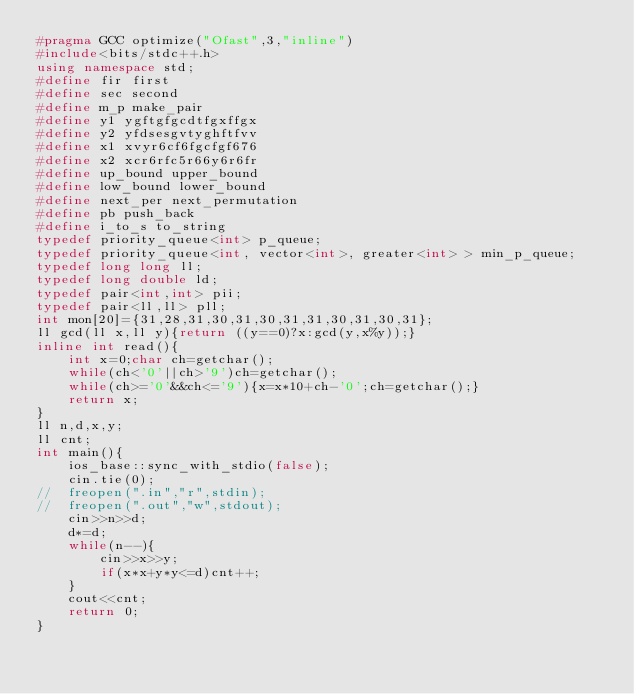<code> <loc_0><loc_0><loc_500><loc_500><_C++_>#pragma GCC optimize("Ofast",3,"inline")
#include<bits/stdc++.h>
using namespace std;
#define fir first
#define sec second
#define m_p make_pair
#define y1 ygftgfgcdtfgxffgx
#define y2 yfdsesgvtyghftfvv
#define x1 xvyr6cf6fgcfgf676
#define x2 xcr6rfc5r66y6r6fr
#define up_bound upper_bound
#define low_bound lower_bound
#define next_per next_permutation
#define pb push_back
#define i_to_s to_string
typedef priority_queue<int> p_queue;
typedef priority_queue<int, vector<int>, greater<int> > min_p_queue;
typedef long long ll;
typedef long double ld;
typedef pair<int,int> pii;
typedef pair<ll,ll> pll;
int mon[20]={31,28,31,30,31,30,31,31,30,31,30,31};
ll gcd(ll x,ll y){return ((y==0)?x:gcd(y,x%y));}
inline int read(){
	int x=0;char ch=getchar();
	while(ch<'0'||ch>'9')ch=getchar();
	while(ch>='0'&&ch<='9'){x=x*10+ch-'0';ch=getchar();}
	return x;
}
ll n,d,x,y;
ll cnt;
int main(){
	ios_base::sync_with_stdio(false);
	cin.tie(0);
//	freopen(".in","r",stdin);
//	freopen(".out","w",stdout);
	cin>>n>>d;
	d*=d;
	while(n--){
		cin>>x>>y;
		if(x*x+y*y<=d)cnt++;
	}
	cout<<cnt;
	return 0;
}

</code> 